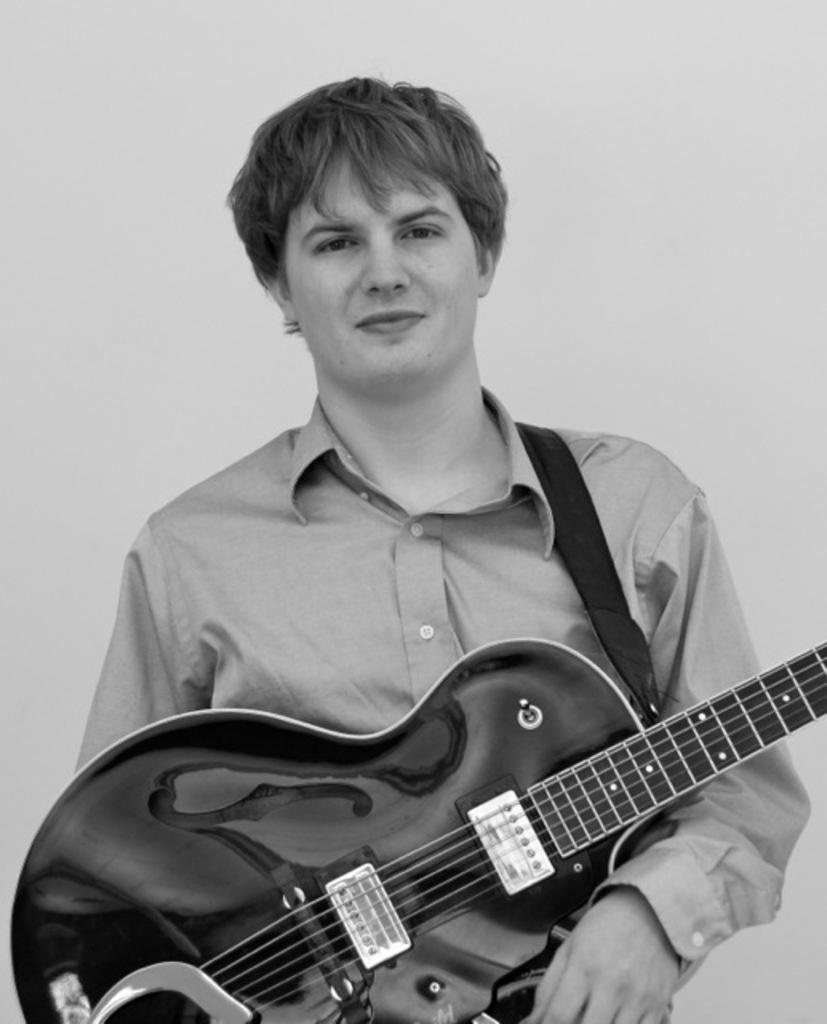What is the main subject of the image? There is a man in the image. What is the man holding in the image? The man is holding a guitar. What is the color scheme of the image? The image is in black and white color. What type of sock is the man wearing in the image? There is no information about the man's socks in the image, as it is in black and white color and focuses on the man holding a guitar. 